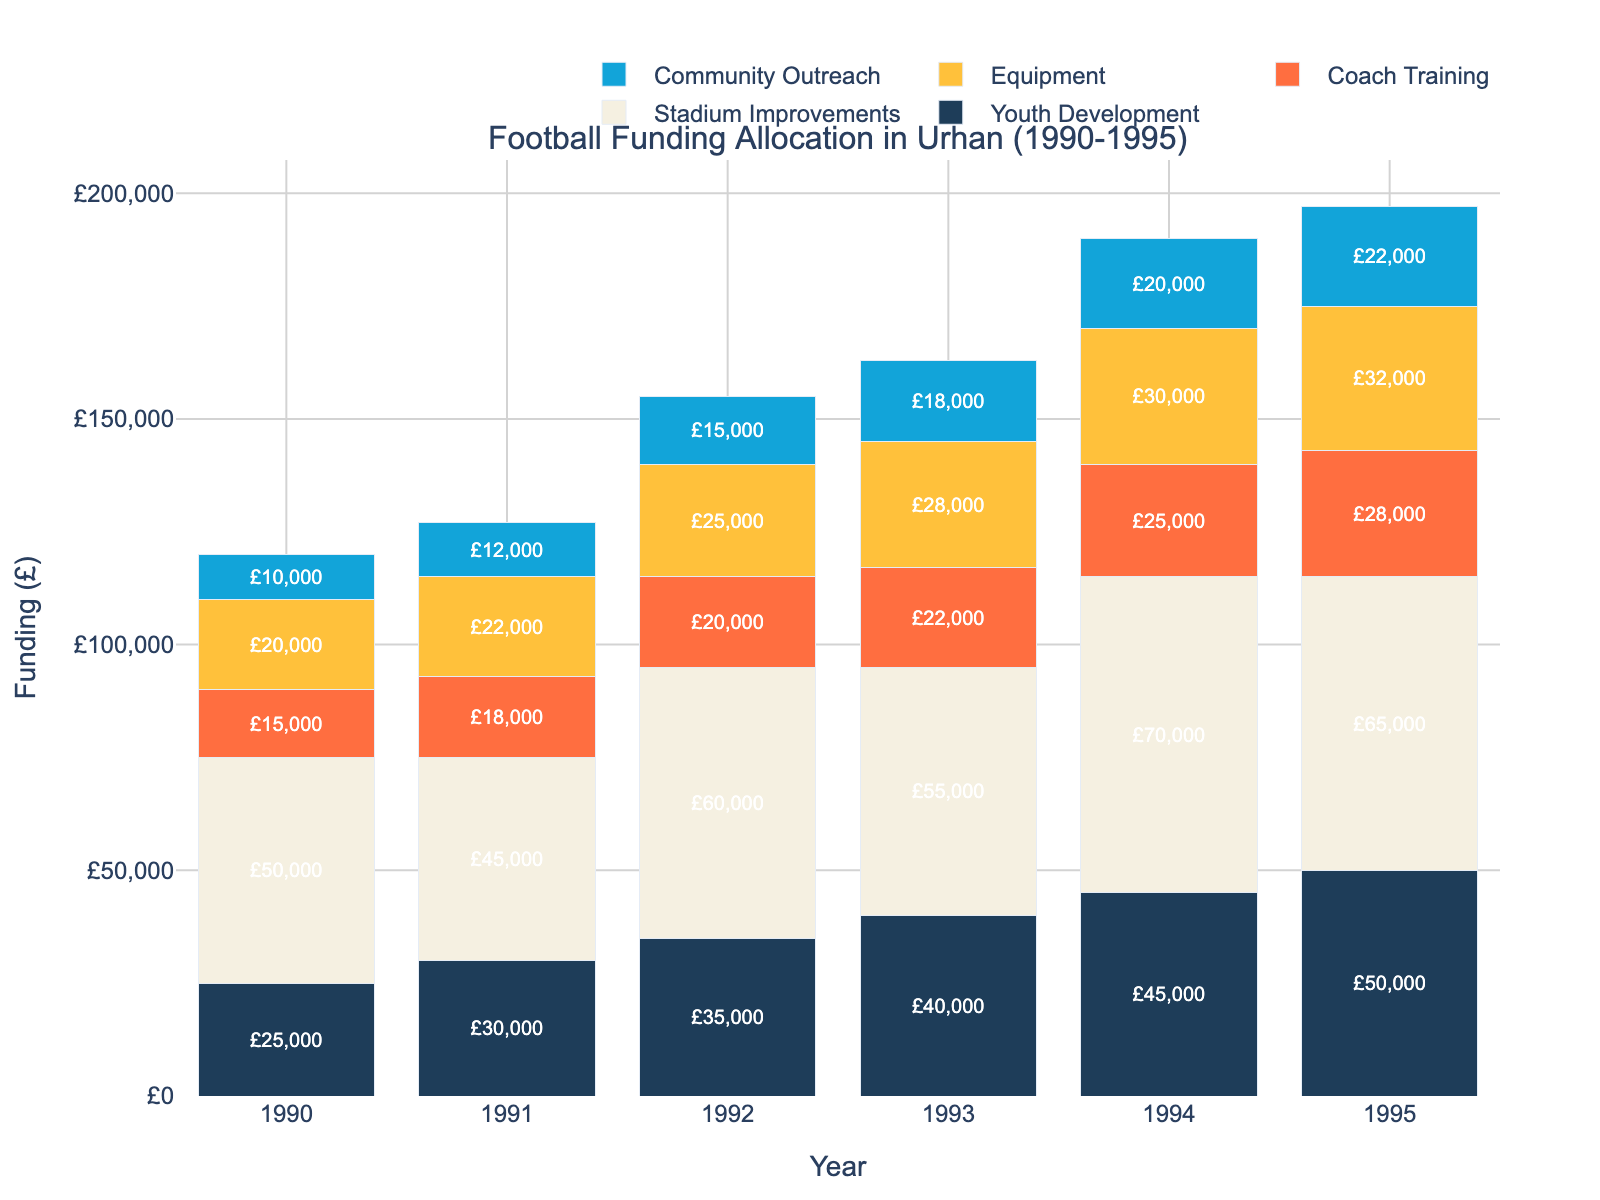Which year saw the highest total funding for football-related initiatives in Urhan? Summing up the funding amounts for each initiative for each year and comparing the sums reveals that 1995 had the highest total funding.
Answer: 1995 How much more funding was allocated to Stadium Improvements in 1994 compared to 1992? The funding for Stadium Improvements in 1994 was £70,000 and in 1992 was £60,000. The difference is £70,000 - £60,000 = £10,000.
Answer: £10,000 Which initiative consistently received increasing funding each year from 1990 to 1995? By checking each initiative's yearly funding, we see that Youth Development received incrementally increasing funding from £25,000 in 1990 to £50,000 in 1995.
Answer: Youth Development What was the total funding allocated to Community Outreach over the six years? Adding the funding amounts for Community Outreach from each year gives: £10,000 + £12,000 + £15,000 + £18,000 + £20,000 + £22,000 = £97,000.
Answer: £97,000 Between Coach Training and Equipment, which received more funding in 1993? Looking at the bar chart for 1993, Coach Training was allocated £22,000 whereas Equipment received £28,000, so Equipment got more funding.
Answer: Equipment In which year was the funding for Equipment the highest? The tallest bar for Equipment is in 1995, where the funding reaches £32,000.
Answer: 1995 What is the average annual funding for Youth Development over the period 1990-1995? The sum of Youth Development funding across these years is £25,000 + £30,000 + £35,000 + £40,000 + £45,000 + £50,000 = £225,000. Dividing by 6 years, the average annual funding is £225,000 / 6 = £37,500.
Answer: £37,500 By how much did the total funding for football-related initiatives increase from 1990 to 1995? Calculating the total funding for 1990 and 1995: For 1990, the funding was £25,000 + £50,000 + £15,000 + £20,000 + £10,000 = £120,000. For 1995, it was £50,000 + £65,000 + £28,000 + £32,000 + £22,000 = £197,000. The increase is £197,000 - £120,000 = £77,000.
Answer: £77,000 